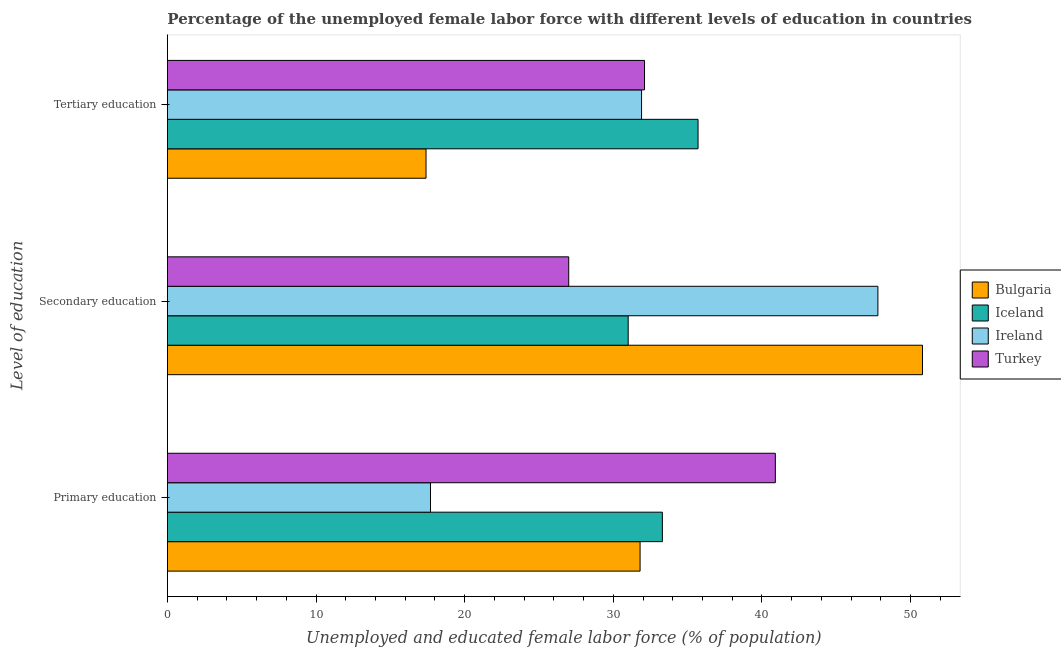How many different coloured bars are there?
Provide a succinct answer. 4. Are the number of bars per tick equal to the number of legend labels?
Your answer should be very brief. Yes. Are the number of bars on each tick of the Y-axis equal?
Provide a succinct answer. Yes. How many bars are there on the 1st tick from the top?
Your answer should be compact. 4. What is the label of the 1st group of bars from the top?
Offer a terse response. Tertiary education. What is the percentage of female labor force who received secondary education in Ireland?
Offer a very short reply. 47.8. Across all countries, what is the maximum percentage of female labor force who received tertiary education?
Keep it short and to the point. 35.7. Across all countries, what is the minimum percentage of female labor force who received secondary education?
Ensure brevity in your answer.  27. In which country was the percentage of female labor force who received primary education minimum?
Your answer should be very brief. Ireland. What is the total percentage of female labor force who received tertiary education in the graph?
Provide a succinct answer. 117.1. What is the difference between the percentage of female labor force who received primary education in Bulgaria and that in Turkey?
Keep it short and to the point. -9.1. What is the difference between the percentage of female labor force who received primary education in Ireland and the percentage of female labor force who received tertiary education in Turkey?
Your answer should be very brief. -14.4. What is the average percentage of female labor force who received primary education per country?
Provide a succinct answer. 30.93. What is the difference between the percentage of female labor force who received tertiary education and percentage of female labor force who received secondary education in Bulgaria?
Offer a terse response. -33.4. What is the ratio of the percentage of female labor force who received primary education in Ireland to that in Bulgaria?
Your answer should be very brief. 0.56. What is the difference between the highest and the second highest percentage of female labor force who received tertiary education?
Provide a succinct answer. 3.6. What is the difference between the highest and the lowest percentage of female labor force who received secondary education?
Provide a succinct answer. 23.8. In how many countries, is the percentage of female labor force who received primary education greater than the average percentage of female labor force who received primary education taken over all countries?
Your answer should be very brief. 3. How many countries are there in the graph?
Offer a terse response. 4. Does the graph contain grids?
Offer a very short reply. No. How many legend labels are there?
Provide a short and direct response. 4. How are the legend labels stacked?
Your answer should be very brief. Vertical. What is the title of the graph?
Your answer should be compact. Percentage of the unemployed female labor force with different levels of education in countries. What is the label or title of the X-axis?
Provide a succinct answer. Unemployed and educated female labor force (% of population). What is the label or title of the Y-axis?
Ensure brevity in your answer.  Level of education. What is the Unemployed and educated female labor force (% of population) of Bulgaria in Primary education?
Make the answer very short. 31.8. What is the Unemployed and educated female labor force (% of population) of Iceland in Primary education?
Make the answer very short. 33.3. What is the Unemployed and educated female labor force (% of population) in Ireland in Primary education?
Provide a short and direct response. 17.7. What is the Unemployed and educated female labor force (% of population) in Turkey in Primary education?
Your answer should be compact. 40.9. What is the Unemployed and educated female labor force (% of population) of Bulgaria in Secondary education?
Keep it short and to the point. 50.8. What is the Unemployed and educated female labor force (% of population) of Ireland in Secondary education?
Provide a succinct answer. 47.8. What is the Unemployed and educated female labor force (% of population) of Turkey in Secondary education?
Your answer should be compact. 27. What is the Unemployed and educated female labor force (% of population) in Bulgaria in Tertiary education?
Your response must be concise. 17.4. What is the Unemployed and educated female labor force (% of population) in Iceland in Tertiary education?
Make the answer very short. 35.7. What is the Unemployed and educated female labor force (% of population) in Ireland in Tertiary education?
Provide a succinct answer. 31.9. What is the Unemployed and educated female labor force (% of population) of Turkey in Tertiary education?
Keep it short and to the point. 32.1. Across all Level of education, what is the maximum Unemployed and educated female labor force (% of population) in Bulgaria?
Your answer should be compact. 50.8. Across all Level of education, what is the maximum Unemployed and educated female labor force (% of population) in Iceland?
Your answer should be compact. 35.7. Across all Level of education, what is the maximum Unemployed and educated female labor force (% of population) of Ireland?
Ensure brevity in your answer.  47.8. Across all Level of education, what is the maximum Unemployed and educated female labor force (% of population) in Turkey?
Provide a succinct answer. 40.9. Across all Level of education, what is the minimum Unemployed and educated female labor force (% of population) of Bulgaria?
Your answer should be very brief. 17.4. Across all Level of education, what is the minimum Unemployed and educated female labor force (% of population) in Iceland?
Keep it short and to the point. 31. Across all Level of education, what is the minimum Unemployed and educated female labor force (% of population) in Ireland?
Offer a very short reply. 17.7. What is the total Unemployed and educated female labor force (% of population) in Iceland in the graph?
Provide a succinct answer. 100. What is the total Unemployed and educated female labor force (% of population) in Ireland in the graph?
Offer a terse response. 97.4. What is the difference between the Unemployed and educated female labor force (% of population) in Bulgaria in Primary education and that in Secondary education?
Provide a succinct answer. -19. What is the difference between the Unemployed and educated female labor force (% of population) of Ireland in Primary education and that in Secondary education?
Provide a short and direct response. -30.1. What is the difference between the Unemployed and educated female labor force (% of population) of Bulgaria in Primary education and that in Tertiary education?
Provide a succinct answer. 14.4. What is the difference between the Unemployed and educated female labor force (% of population) of Iceland in Primary education and that in Tertiary education?
Give a very brief answer. -2.4. What is the difference between the Unemployed and educated female labor force (% of population) of Turkey in Primary education and that in Tertiary education?
Keep it short and to the point. 8.8. What is the difference between the Unemployed and educated female labor force (% of population) of Bulgaria in Secondary education and that in Tertiary education?
Provide a succinct answer. 33.4. What is the difference between the Unemployed and educated female labor force (% of population) of Bulgaria in Primary education and the Unemployed and educated female labor force (% of population) of Turkey in Secondary education?
Make the answer very short. 4.8. What is the difference between the Unemployed and educated female labor force (% of population) of Iceland in Primary education and the Unemployed and educated female labor force (% of population) of Turkey in Secondary education?
Give a very brief answer. 6.3. What is the difference between the Unemployed and educated female labor force (% of population) in Bulgaria in Primary education and the Unemployed and educated female labor force (% of population) in Iceland in Tertiary education?
Give a very brief answer. -3.9. What is the difference between the Unemployed and educated female labor force (% of population) in Bulgaria in Primary education and the Unemployed and educated female labor force (% of population) in Ireland in Tertiary education?
Your response must be concise. -0.1. What is the difference between the Unemployed and educated female labor force (% of population) of Bulgaria in Primary education and the Unemployed and educated female labor force (% of population) of Turkey in Tertiary education?
Your answer should be very brief. -0.3. What is the difference between the Unemployed and educated female labor force (% of population) of Iceland in Primary education and the Unemployed and educated female labor force (% of population) of Ireland in Tertiary education?
Keep it short and to the point. 1.4. What is the difference between the Unemployed and educated female labor force (% of population) in Ireland in Primary education and the Unemployed and educated female labor force (% of population) in Turkey in Tertiary education?
Offer a very short reply. -14.4. What is the difference between the Unemployed and educated female labor force (% of population) in Ireland in Secondary education and the Unemployed and educated female labor force (% of population) in Turkey in Tertiary education?
Give a very brief answer. 15.7. What is the average Unemployed and educated female labor force (% of population) of Bulgaria per Level of education?
Keep it short and to the point. 33.33. What is the average Unemployed and educated female labor force (% of population) in Iceland per Level of education?
Give a very brief answer. 33.33. What is the average Unemployed and educated female labor force (% of population) in Ireland per Level of education?
Provide a succinct answer. 32.47. What is the average Unemployed and educated female labor force (% of population) in Turkey per Level of education?
Keep it short and to the point. 33.33. What is the difference between the Unemployed and educated female labor force (% of population) in Bulgaria and Unemployed and educated female labor force (% of population) in Ireland in Primary education?
Make the answer very short. 14.1. What is the difference between the Unemployed and educated female labor force (% of population) in Iceland and Unemployed and educated female labor force (% of population) in Ireland in Primary education?
Ensure brevity in your answer.  15.6. What is the difference between the Unemployed and educated female labor force (% of population) of Iceland and Unemployed and educated female labor force (% of population) of Turkey in Primary education?
Your answer should be compact. -7.6. What is the difference between the Unemployed and educated female labor force (% of population) in Ireland and Unemployed and educated female labor force (% of population) in Turkey in Primary education?
Provide a short and direct response. -23.2. What is the difference between the Unemployed and educated female labor force (% of population) in Bulgaria and Unemployed and educated female labor force (% of population) in Iceland in Secondary education?
Keep it short and to the point. 19.8. What is the difference between the Unemployed and educated female labor force (% of population) of Bulgaria and Unemployed and educated female labor force (% of population) of Turkey in Secondary education?
Provide a short and direct response. 23.8. What is the difference between the Unemployed and educated female labor force (% of population) of Iceland and Unemployed and educated female labor force (% of population) of Ireland in Secondary education?
Your answer should be compact. -16.8. What is the difference between the Unemployed and educated female labor force (% of population) in Iceland and Unemployed and educated female labor force (% of population) in Turkey in Secondary education?
Ensure brevity in your answer.  4. What is the difference between the Unemployed and educated female labor force (% of population) of Ireland and Unemployed and educated female labor force (% of population) of Turkey in Secondary education?
Your response must be concise. 20.8. What is the difference between the Unemployed and educated female labor force (% of population) in Bulgaria and Unemployed and educated female labor force (% of population) in Iceland in Tertiary education?
Provide a succinct answer. -18.3. What is the difference between the Unemployed and educated female labor force (% of population) in Bulgaria and Unemployed and educated female labor force (% of population) in Turkey in Tertiary education?
Provide a succinct answer. -14.7. What is the ratio of the Unemployed and educated female labor force (% of population) of Bulgaria in Primary education to that in Secondary education?
Give a very brief answer. 0.63. What is the ratio of the Unemployed and educated female labor force (% of population) in Iceland in Primary education to that in Secondary education?
Your response must be concise. 1.07. What is the ratio of the Unemployed and educated female labor force (% of population) of Ireland in Primary education to that in Secondary education?
Your answer should be very brief. 0.37. What is the ratio of the Unemployed and educated female labor force (% of population) of Turkey in Primary education to that in Secondary education?
Your answer should be very brief. 1.51. What is the ratio of the Unemployed and educated female labor force (% of population) of Bulgaria in Primary education to that in Tertiary education?
Ensure brevity in your answer.  1.83. What is the ratio of the Unemployed and educated female labor force (% of population) of Iceland in Primary education to that in Tertiary education?
Your answer should be compact. 0.93. What is the ratio of the Unemployed and educated female labor force (% of population) of Ireland in Primary education to that in Tertiary education?
Provide a short and direct response. 0.55. What is the ratio of the Unemployed and educated female labor force (% of population) in Turkey in Primary education to that in Tertiary education?
Provide a succinct answer. 1.27. What is the ratio of the Unemployed and educated female labor force (% of population) in Bulgaria in Secondary education to that in Tertiary education?
Your answer should be compact. 2.92. What is the ratio of the Unemployed and educated female labor force (% of population) of Iceland in Secondary education to that in Tertiary education?
Make the answer very short. 0.87. What is the ratio of the Unemployed and educated female labor force (% of population) in Ireland in Secondary education to that in Tertiary education?
Your response must be concise. 1.5. What is the ratio of the Unemployed and educated female labor force (% of population) of Turkey in Secondary education to that in Tertiary education?
Your response must be concise. 0.84. What is the difference between the highest and the second highest Unemployed and educated female labor force (% of population) in Bulgaria?
Offer a terse response. 19. What is the difference between the highest and the second highest Unemployed and educated female labor force (% of population) of Iceland?
Your response must be concise. 2.4. What is the difference between the highest and the second highest Unemployed and educated female labor force (% of population) of Ireland?
Provide a short and direct response. 15.9. What is the difference between the highest and the lowest Unemployed and educated female labor force (% of population) in Bulgaria?
Give a very brief answer. 33.4. What is the difference between the highest and the lowest Unemployed and educated female labor force (% of population) of Iceland?
Offer a very short reply. 4.7. What is the difference between the highest and the lowest Unemployed and educated female labor force (% of population) of Ireland?
Provide a short and direct response. 30.1. What is the difference between the highest and the lowest Unemployed and educated female labor force (% of population) of Turkey?
Make the answer very short. 13.9. 